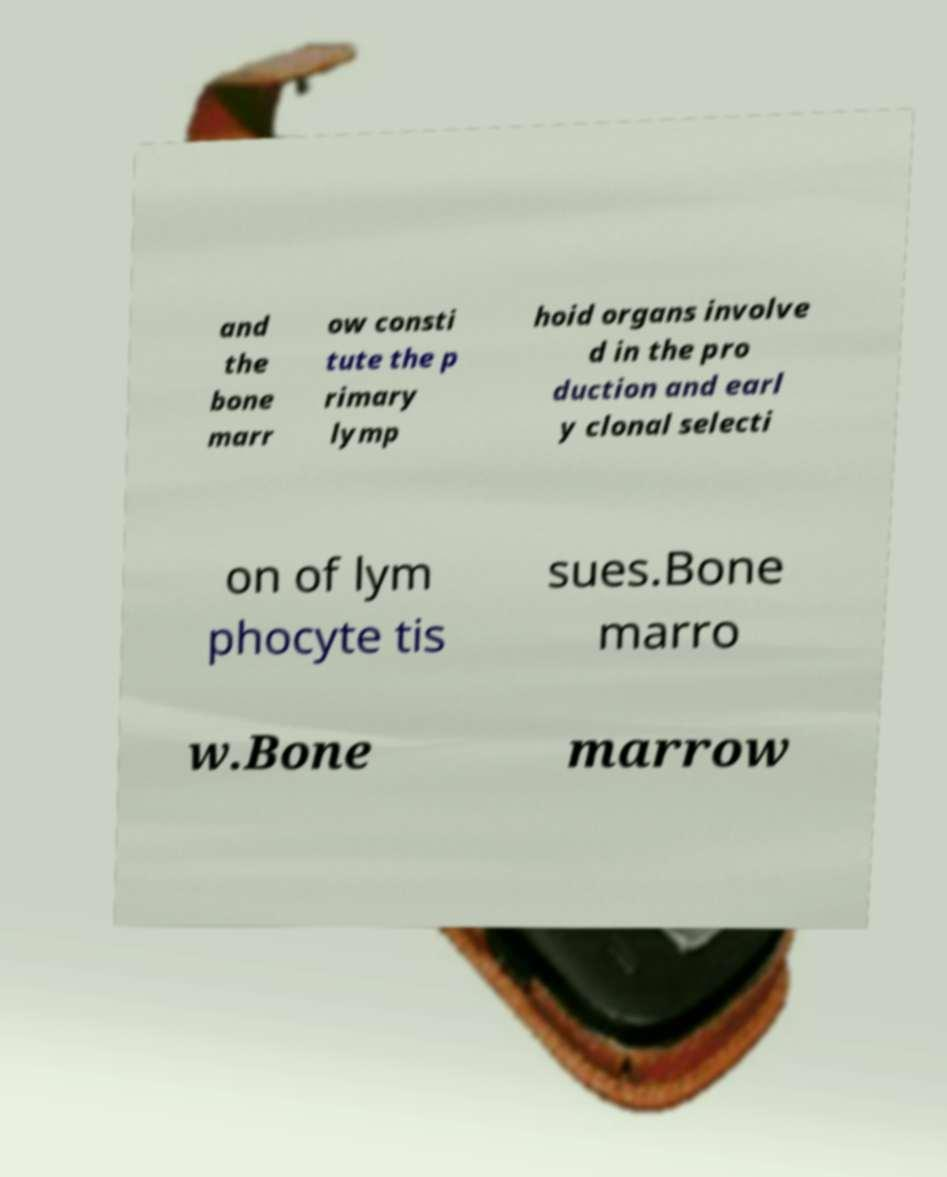For documentation purposes, I need the text within this image transcribed. Could you provide that? and the bone marr ow consti tute the p rimary lymp hoid organs involve d in the pro duction and earl y clonal selecti on of lym phocyte tis sues.Bone marro w.Bone marrow 